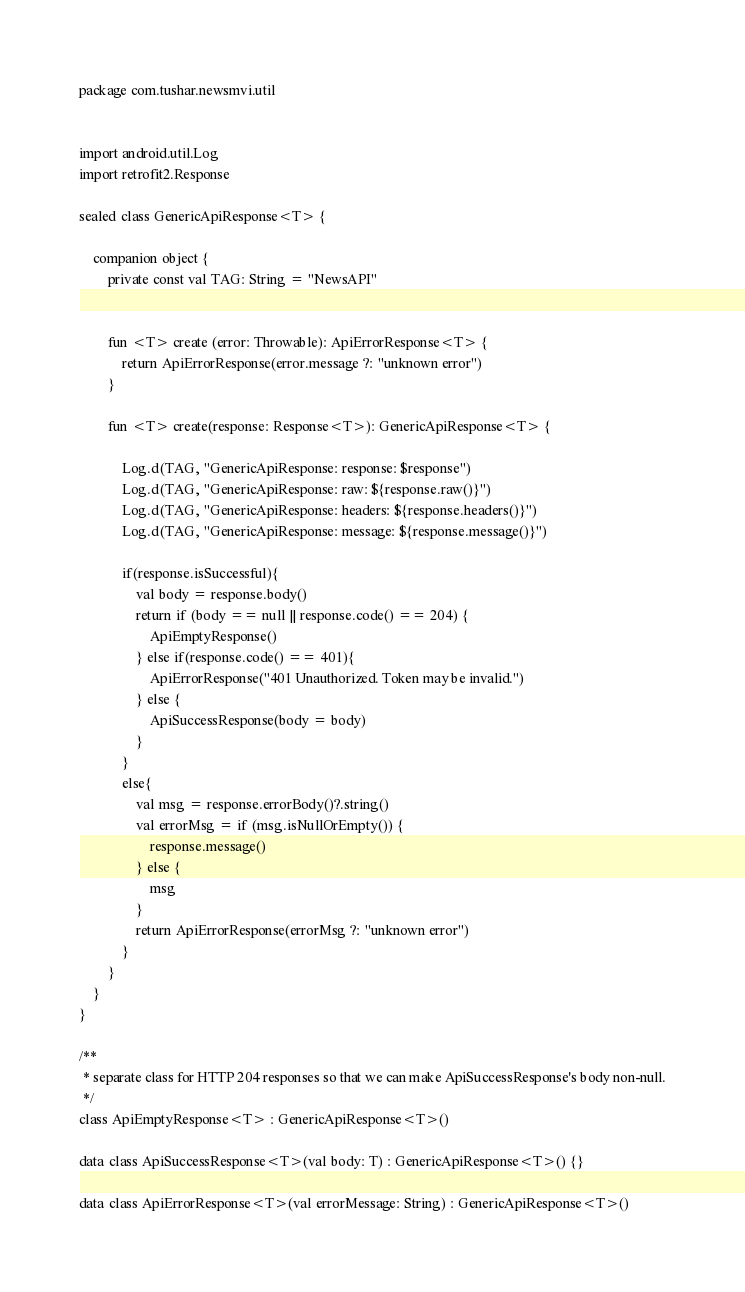Convert code to text. <code><loc_0><loc_0><loc_500><loc_500><_Kotlin_>package com.tushar.newsmvi.util


import android.util.Log
import retrofit2.Response

sealed class GenericApiResponse<T> {

    companion object {
        private const val TAG: String = "NewsAPI"


        fun <T> create (error: Throwable): ApiErrorResponse<T> {
            return ApiErrorResponse(error.message ?: "unknown error")
        }

        fun <T> create(response: Response<T>): GenericApiResponse<T> {

            Log.d(TAG, "GenericApiResponse: response: $response")
            Log.d(TAG, "GenericApiResponse: raw: ${response.raw()}")
            Log.d(TAG, "GenericApiResponse: headers: ${response.headers()}")
            Log.d(TAG, "GenericApiResponse: message: ${response.message()}")

            if(response.isSuccessful){
                val body = response.body()
                return if (body == null || response.code() == 204) {
                    ApiEmptyResponse()
                } else if(response.code() == 401){
                    ApiErrorResponse("401 Unauthorized. Token may be invalid.")
                } else {
                    ApiSuccessResponse(body = body)
                }
            }
            else{
                val msg = response.errorBody()?.string()
                val errorMsg = if (msg.isNullOrEmpty()) {
                    response.message()
                } else {
                    msg
                }
                return ApiErrorResponse(errorMsg ?: "unknown error")
            }
        }
    }
}

/**
 * separate class for HTTP 204 responses so that we can make ApiSuccessResponse's body non-null.
 */
class ApiEmptyResponse<T> : GenericApiResponse<T>()

data class ApiSuccessResponse<T>(val body: T) : GenericApiResponse<T>() {}

data class ApiErrorResponse<T>(val errorMessage: String) : GenericApiResponse<T>()
</code> 